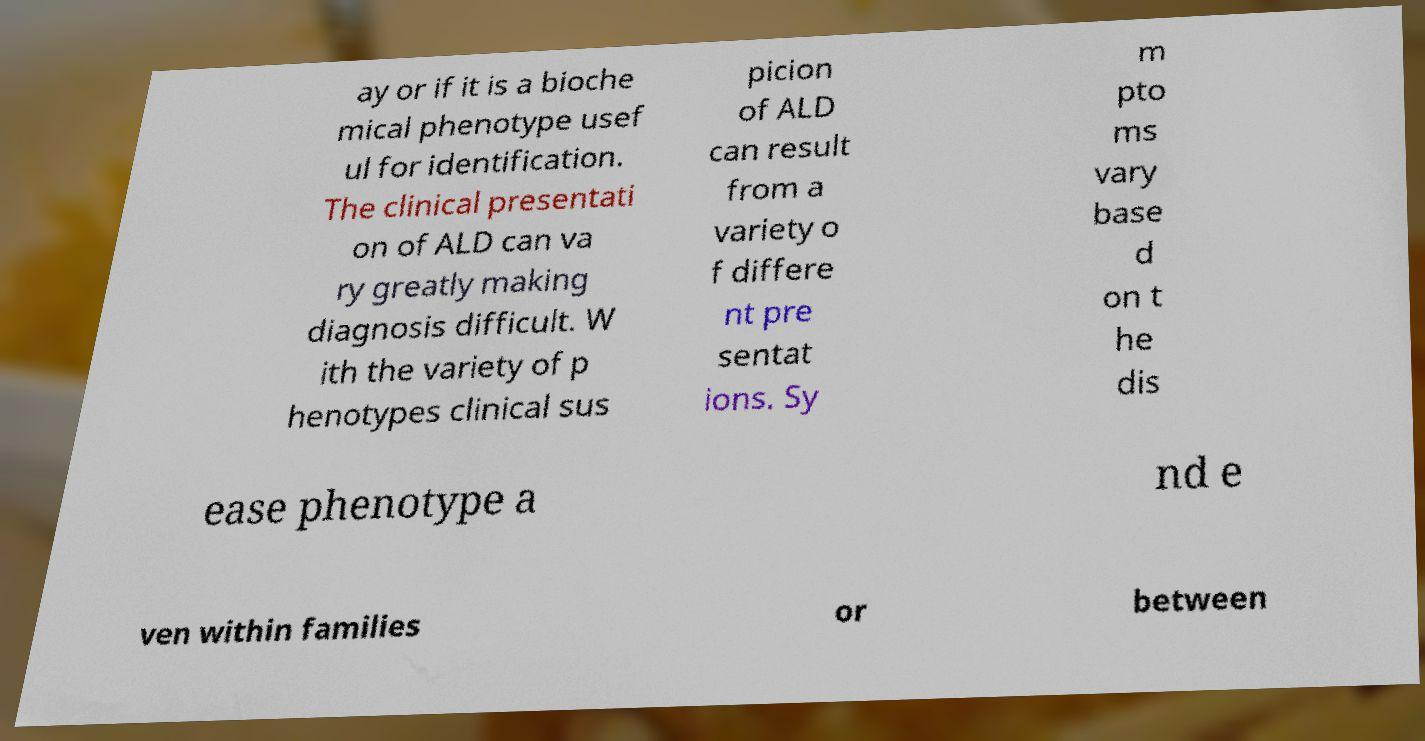Please identify and transcribe the text found in this image. ay or if it is a bioche mical phenotype usef ul for identification. The clinical presentati on of ALD can va ry greatly making diagnosis difficult. W ith the variety of p henotypes clinical sus picion of ALD can result from a variety o f differe nt pre sentat ions. Sy m pto ms vary base d on t he dis ease phenotype a nd e ven within families or between 